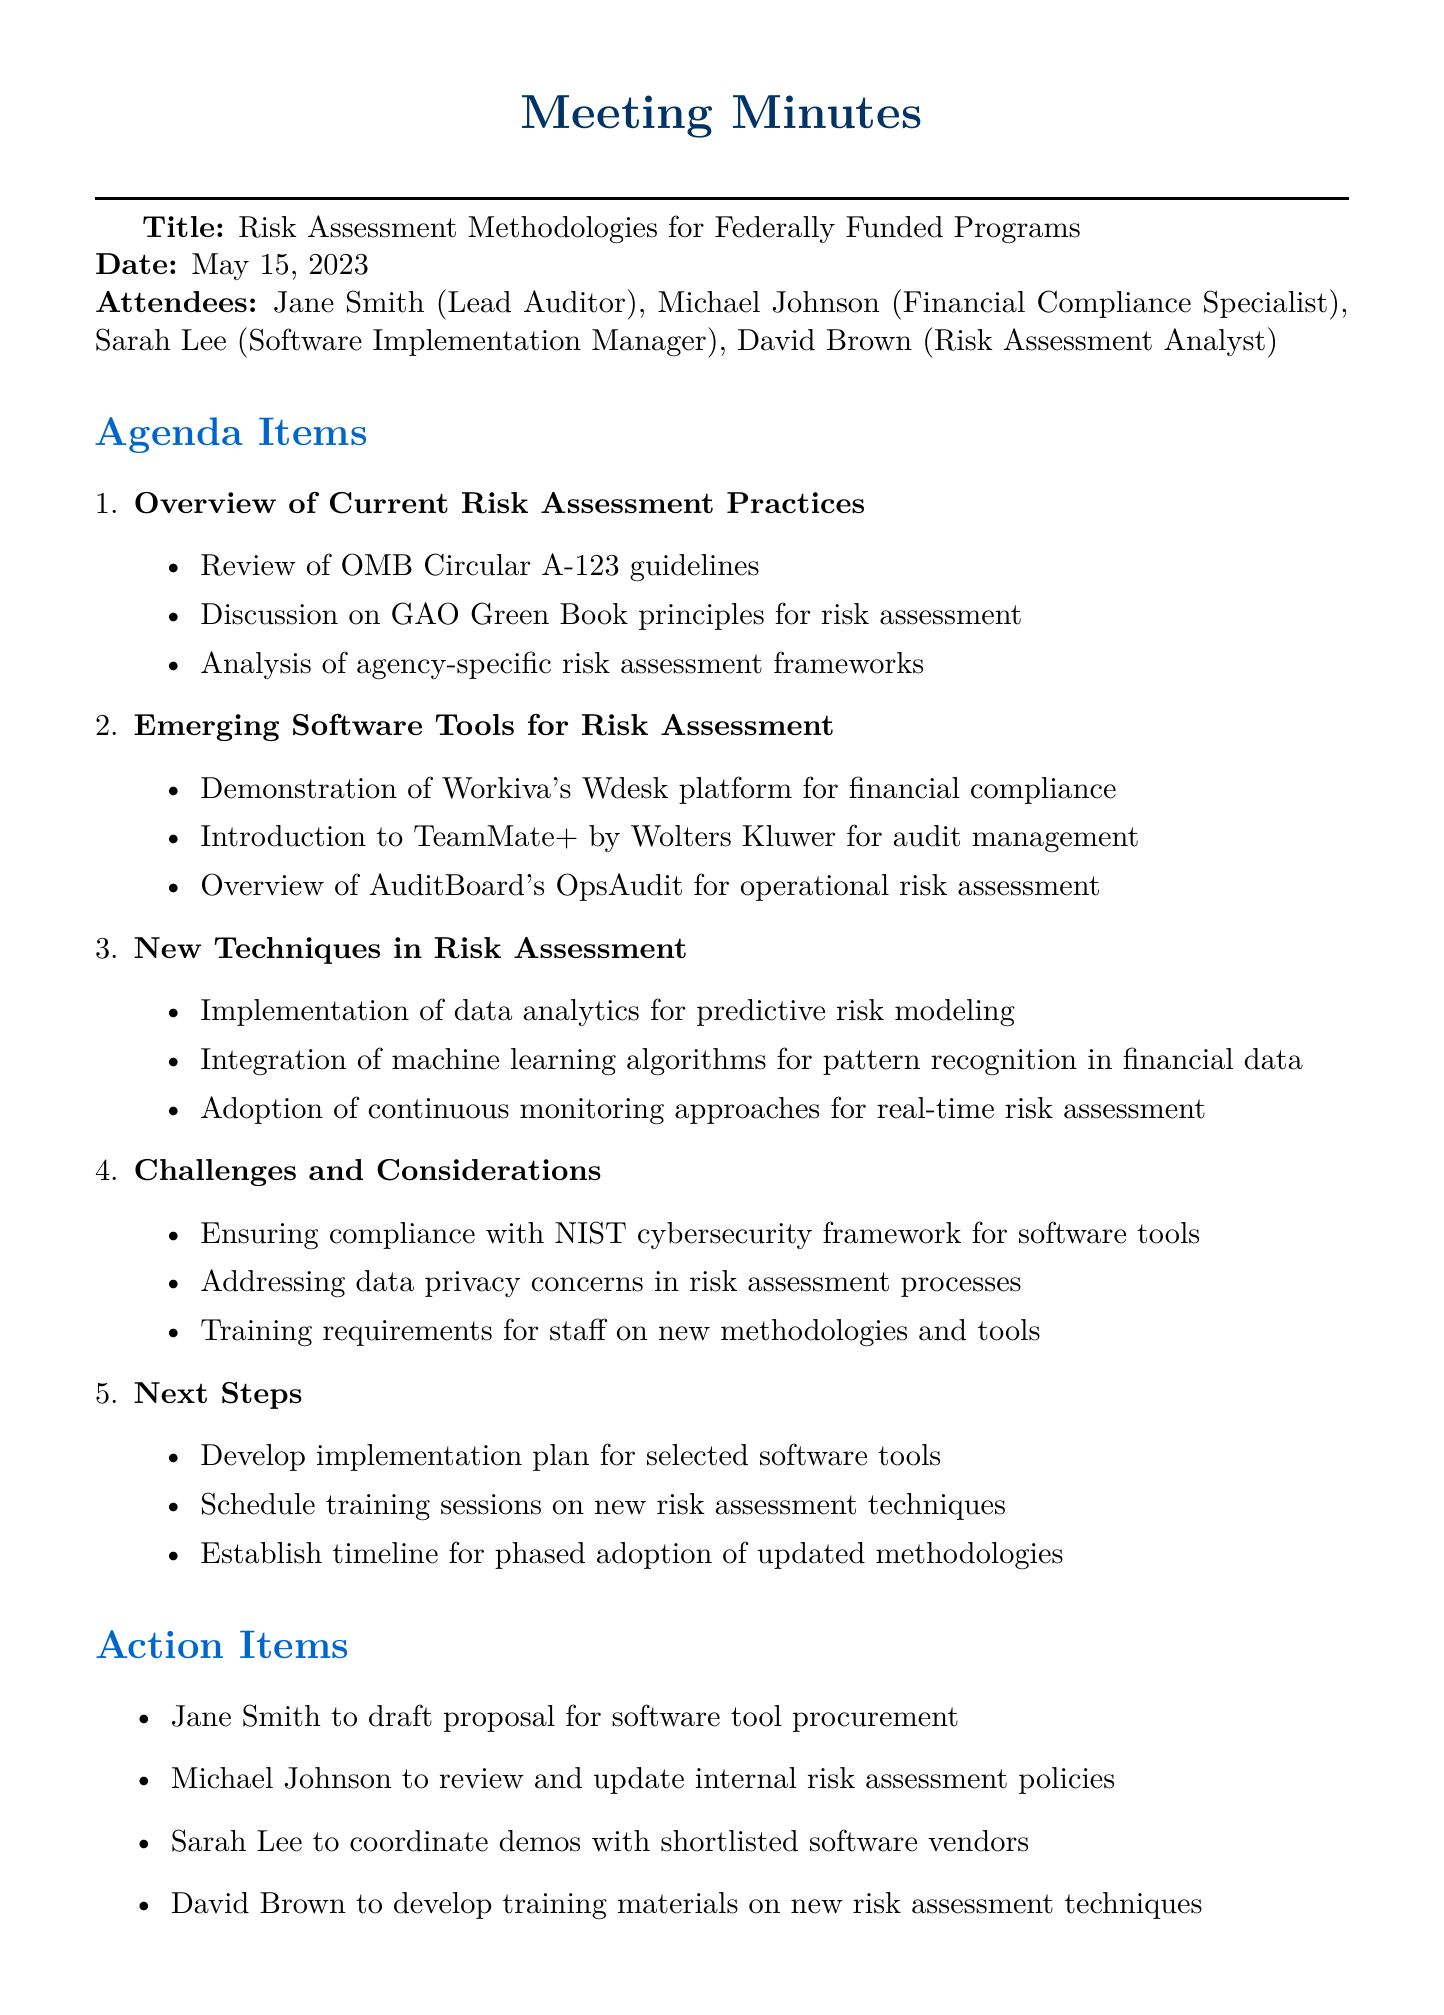What is the title of the meeting? The title of the meeting is located at the top of the document under "Title."
Answer: Risk Assessment Methodologies for Federally Funded Programs Who is the Lead Auditor present at the meeting? The Lead Auditor's name is listed in the attendees section.
Answer: Jane Smith What are the three software tools introduced for risk assessment? This information can be found in the agenda item "Emerging Software Tools for Risk Assessment."
Answer: Workiva's Wdesk, TeamMate+, AuditBoard's OpsAudit What date was the meeting held? The meeting date is stated below the title in the document.
Answer: May 15, 2023 What is the first action item assigned to Jane Smith? This can be found in the action items section of the document.
Answer: Draft proposal for software tool procurement Which agenda item focuses on implementation methods for risk assessment? The agenda item title provides insight into this topic.
Answer: New Techniques in Risk Assessment How many attendees were present at the meeting? The number of attendees is counted in the list provided.
Answer: Four What is one of the challenges discussed regarding software tools? This information can be located in the "Challenges and Considerations" agenda item.
Answer: Compliance with NIST cybersecurity framework 